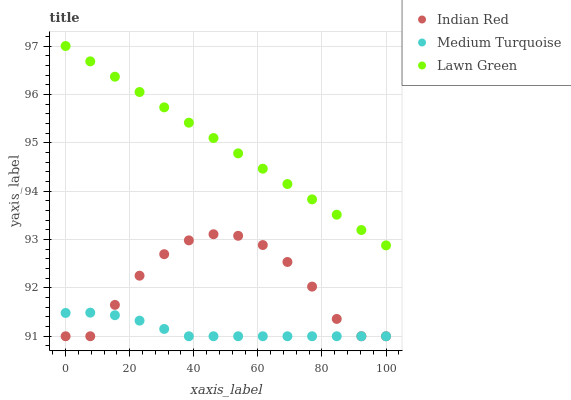Does Medium Turquoise have the minimum area under the curve?
Answer yes or no. Yes. Does Lawn Green have the maximum area under the curve?
Answer yes or no. Yes. Does Indian Red have the minimum area under the curve?
Answer yes or no. No. Does Indian Red have the maximum area under the curve?
Answer yes or no. No. Is Lawn Green the smoothest?
Answer yes or no. Yes. Is Indian Red the roughest?
Answer yes or no. Yes. Is Medium Turquoise the smoothest?
Answer yes or no. No. Is Medium Turquoise the roughest?
Answer yes or no. No. Does Medium Turquoise have the lowest value?
Answer yes or no. Yes. Does Lawn Green have the highest value?
Answer yes or no. Yes. Does Indian Red have the highest value?
Answer yes or no. No. Is Medium Turquoise less than Lawn Green?
Answer yes or no. Yes. Is Lawn Green greater than Indian Red?
Answer yes or no. Yes. Does Medium Turquoise intersect Indian Red?
Answer yes or no. Yes. Is Medium Turquoise less than Indian Red?
Answer yes or no. No. Is Medium Turquoise greater than Indian Red?
Answer yes or no. No. Does Medium Turquoise intersect Lawn Green?
Answer yes or no. No. 